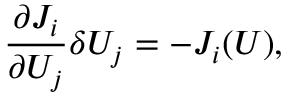Convert formula to latex. <formula><loc_0><loc_0><loc_500><loc_500>\frac { \partial J _ { i } } { \partial U _ { j } } \delta U _ { j } = - J _ { i } ( U ) ,</formula> 